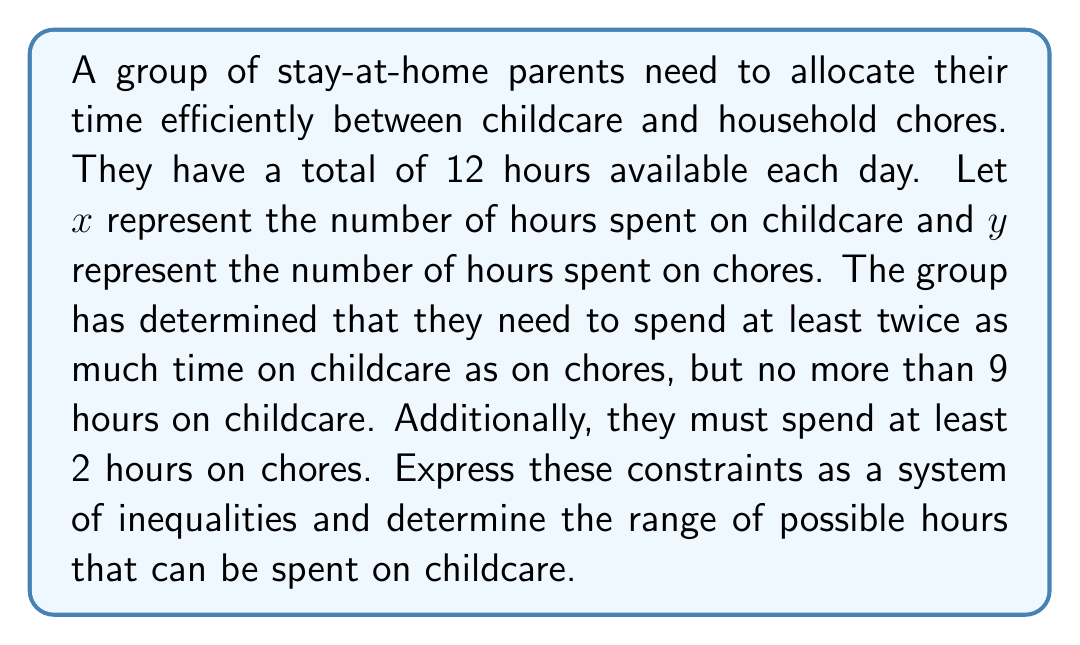Can you answer this question? Let's approach this step-by-step:

1) First, let's define our variables:
   $x$ = hours spent on childcare
   $y$ = hours spent on chores

2) Now, let's express the given constraints as inequalities:

   a) Total time constraint: $x + y = 12$
   b) Childcare should be at least twice chores: $x \geq 2y$
   c) Childcare should not exceed 9 hours: $x \leq 9$
   d) At least 2 hours must be spent on chores: $y \geq 2$

3) From the total time constraint, we can express $y$ in terms of $x$:
   $y = 12 - x$

4) Substituting this into the other inequalities:

   $x \geq 2(12-x)$, which simplifies to $x \geq 8$
   $x \leq 9$
   $12 - x \geq 2$, which simplifies to $x \leq 10$

5) Combining these inequalities:

   $8 \leq x \leq 9$

This is the range of possible hours that can be spent on childcare.
Answer: $8 \leq x \leq 9$ 